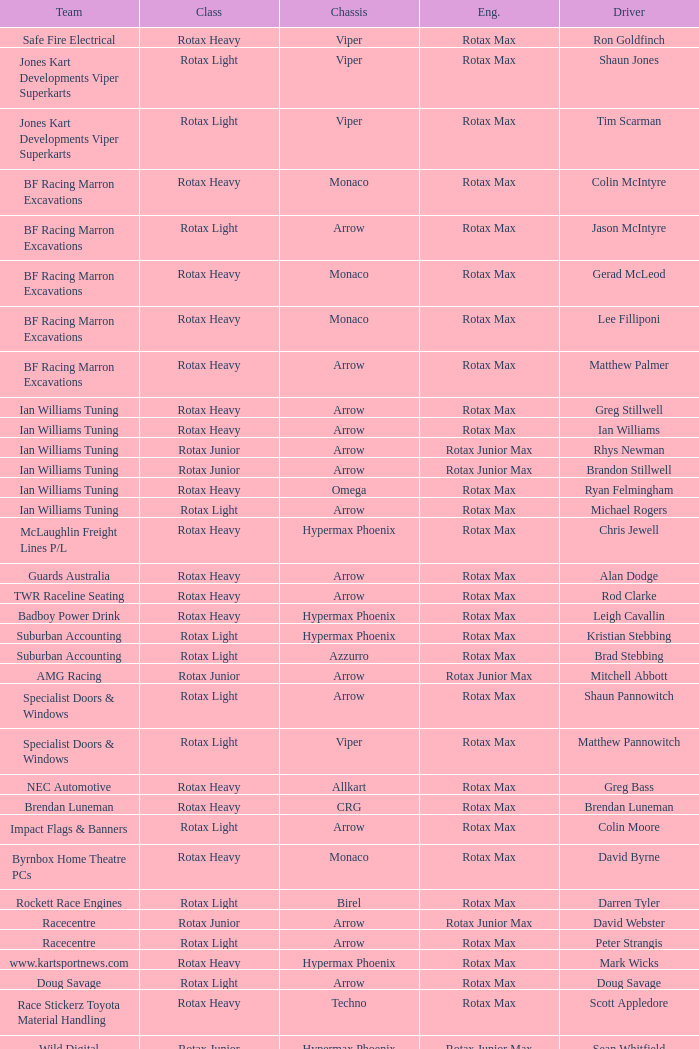What type of engine does the BF Racing Marron Excavations have that also has Monaco as chassis and Lee Filliponi as the driver? Rotax Max. 